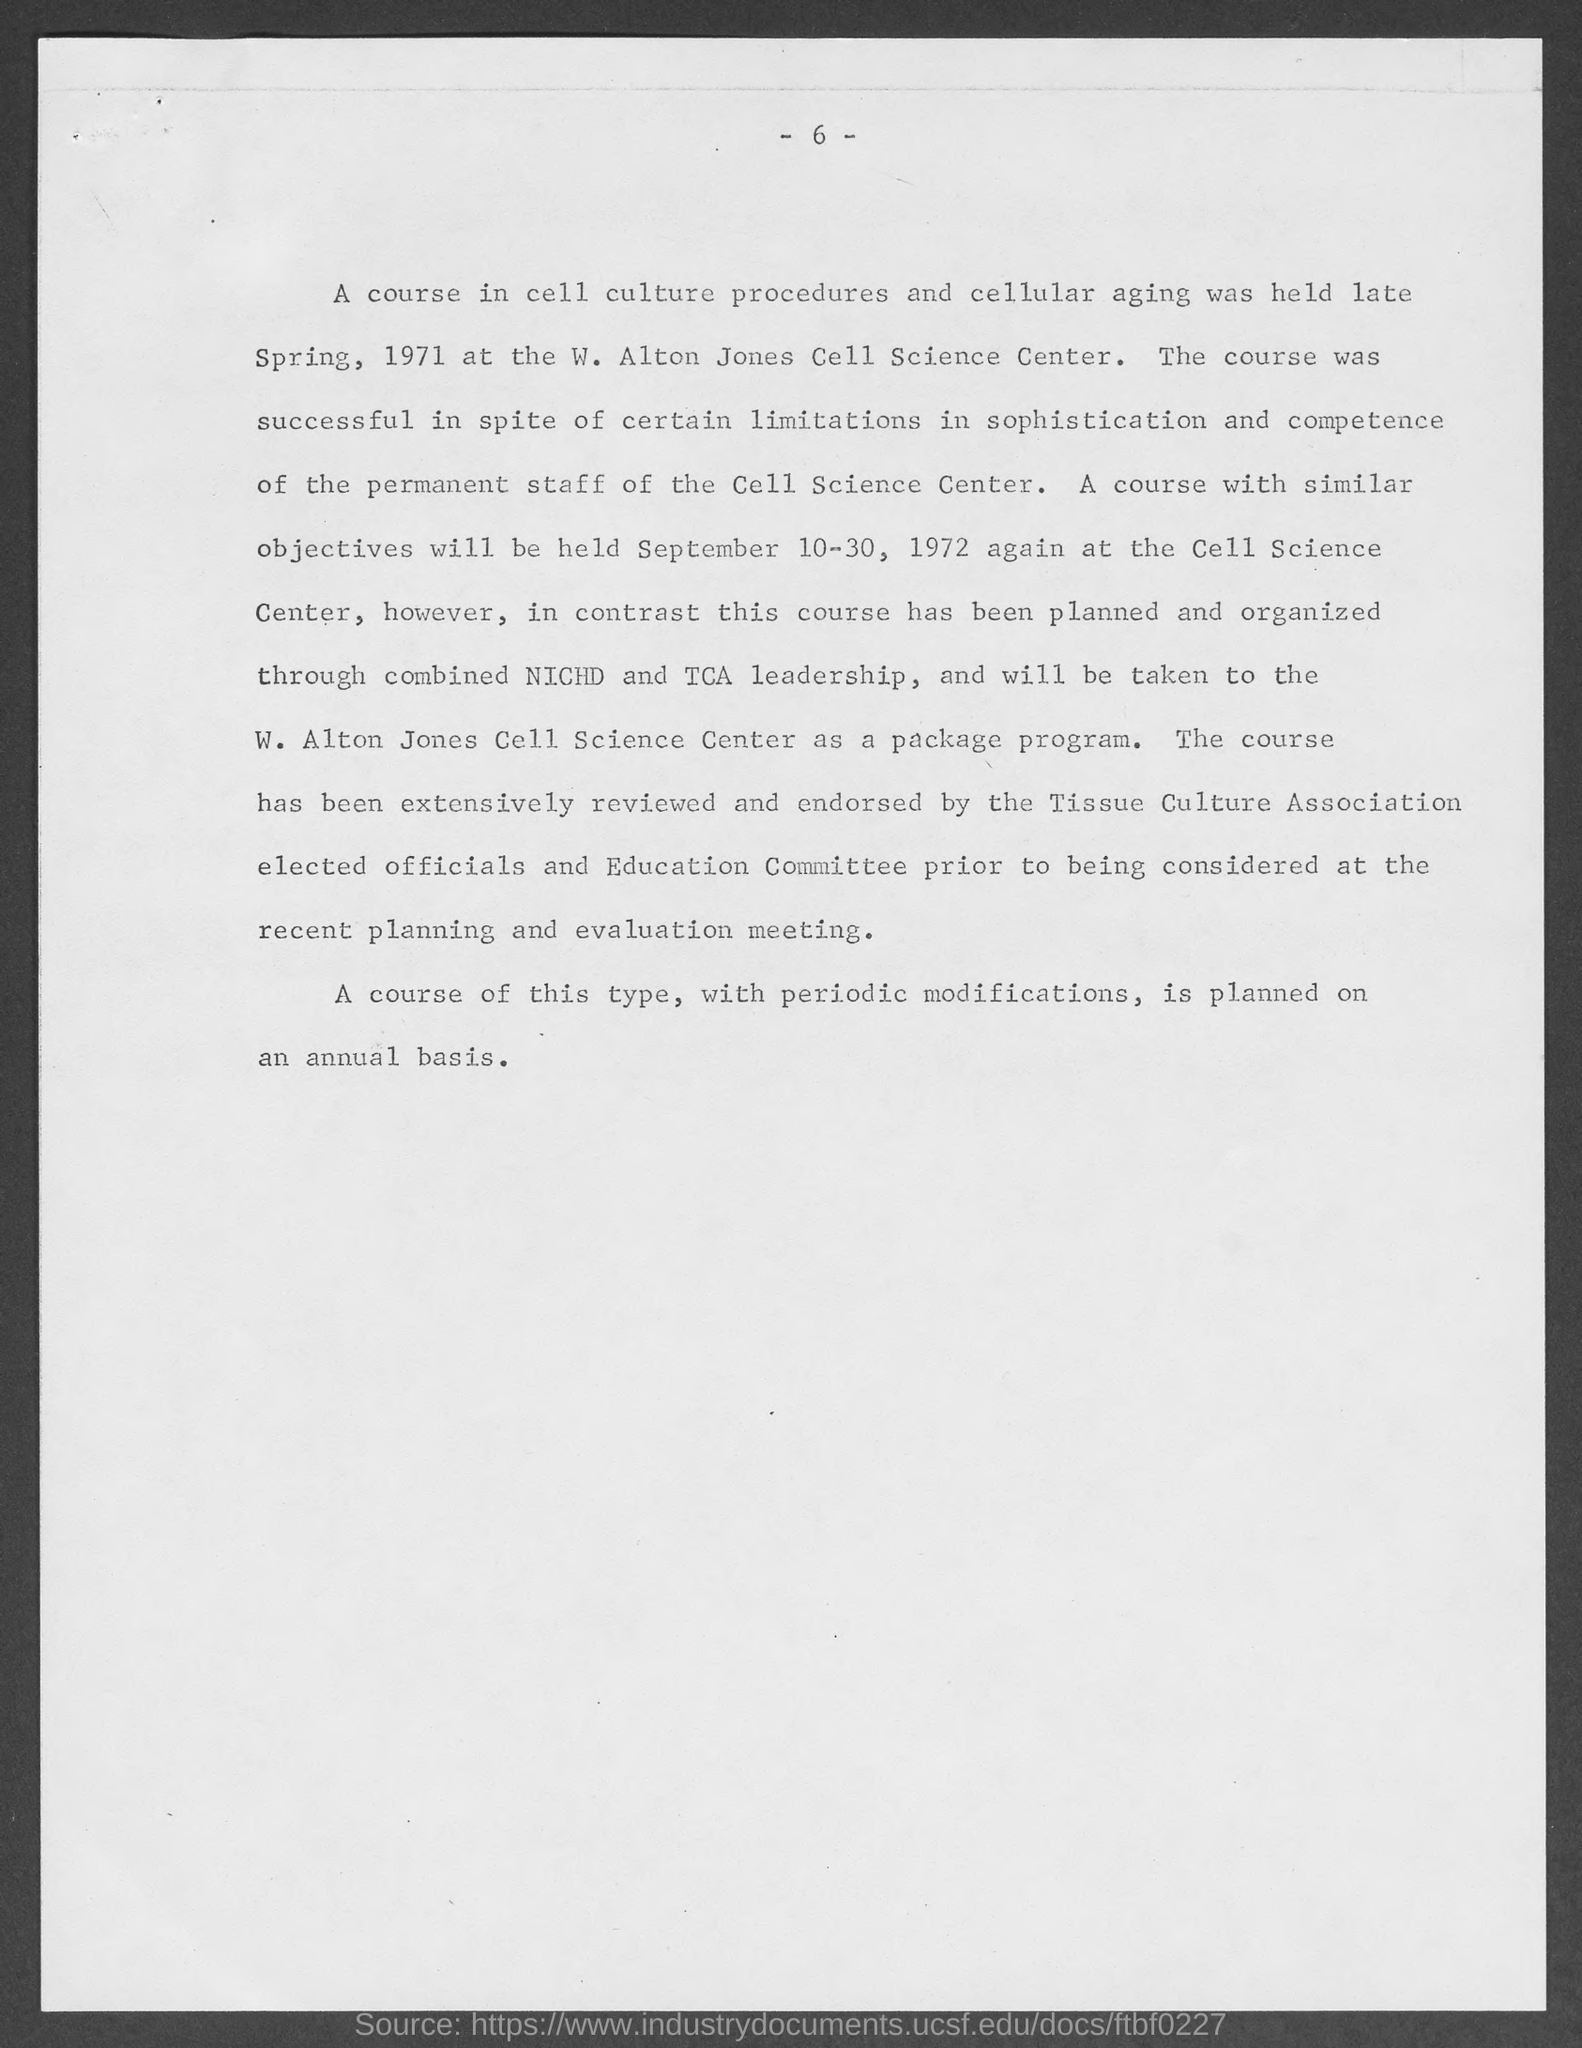Mention a couple of crucial points in this snapshot. The page number mentioned in this document is 6. 